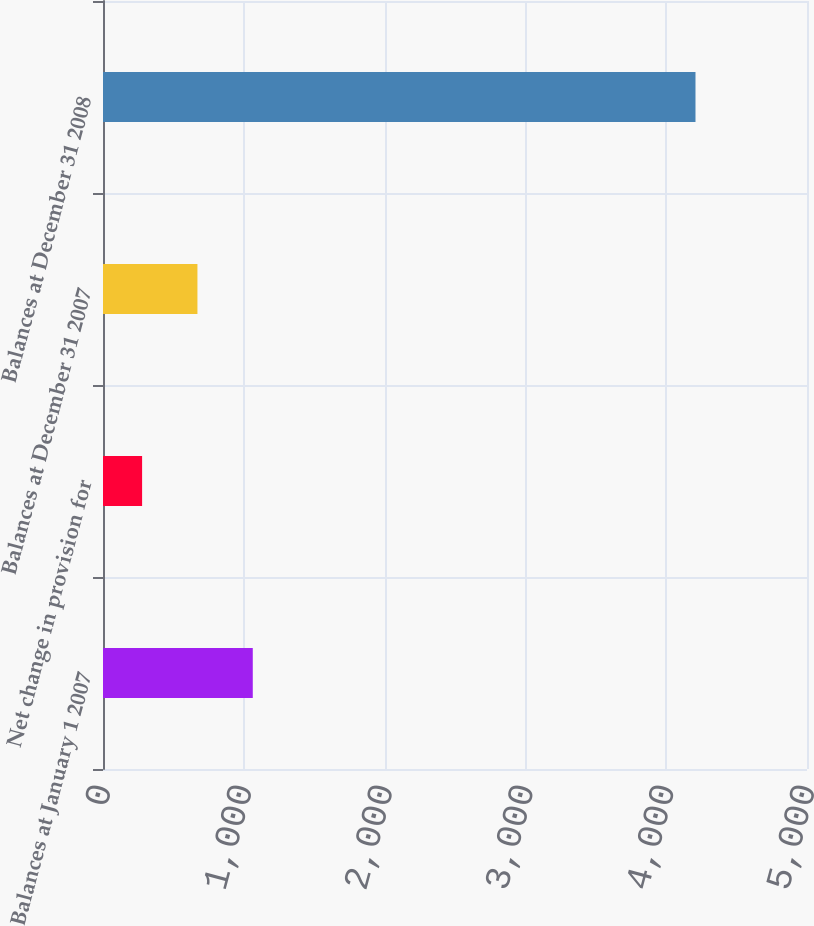Convert chart to OTSL. <chart><loc_0><loc_0><loc_500><loc_500><bar_chart><fcel>Balances at January 1 2007<fcel>Net change in provision for<fcel>Balances at December 31 2007<fcel>Balances at December 31 2008<nl><fcel>1063.76<fcel>277.7<fcel>670.73<fcel>4208<nl></chart> 